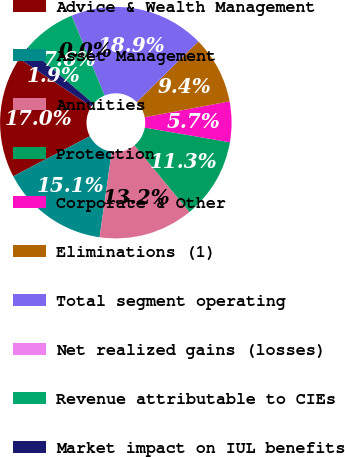<chart> <loc_0><loc_0><loc_500><loc_500><pie_chart><fcel>Advice & Wealth Management<fcel>Asset Management<fcel>Annuities<fcel>Protection<fcel>Corporate & Other<fcel>Eliminations (1)<fcel>Total segment operating<fcel>Net realized gains (losses)<fcel>Revenue attributable to CIEs<fcel>Market impact on IUL benefits<nl><fcel>16.98%<fcel>15.09%<fcel>13.21%<fcel>11.32%<fcel>5.66%<fcel>9.43%<fcel>18.86%<fcel>0.01%<fcel>7.55%<fcel>1.89%<nl></chart> 